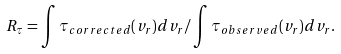<formula> <loc_0><loc_0><loc_500><loc_500>R _ { \tau } = \int \tau _ { c o r r e c t e d } ( v _ { r } ) d v _ { r } / \int \tau _ { o b s e r v e d } ( v _ { r } ) d v _ { r } .</formula> 